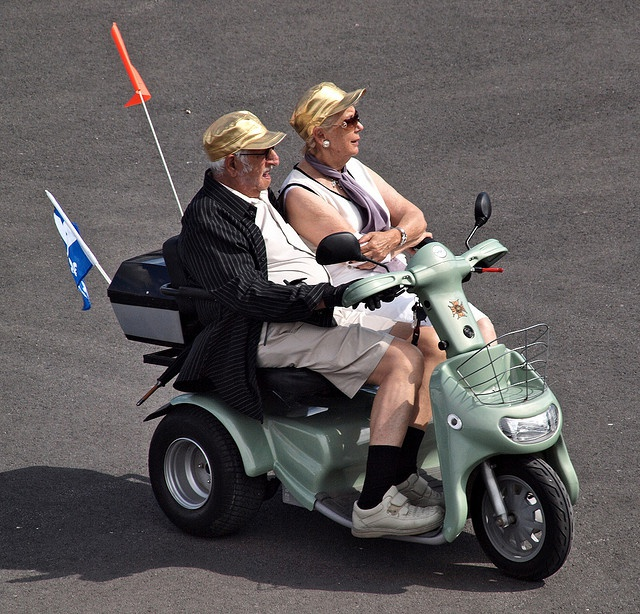Describe the objects in this image and their specific colors. I can see motorcycle in gray, black, darkgray, and ivory tones, people in gray, black, and white tones, and people in gray, white, brown, and tan tones in this image. 